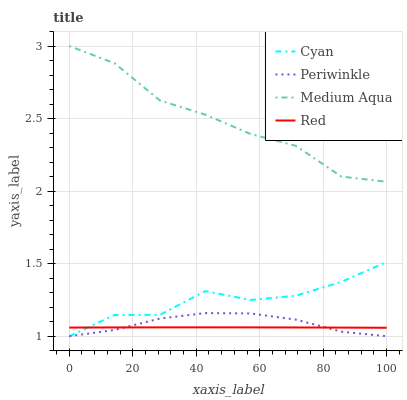Does Red have the minimum area under the curve?
Answer yes or no. Yes. Does Medium Aqua have the maximum area under the curve?
Answer yes or no. Yes. Does Cyan have the minimum area under the curve?
Answer yes or no. No. Does Cyan have the maximum area under the curve?
Answer yes or no. No. Is Red the smoothest?
Answer yes or no. Yes. Is Cyan the roughest?
Answer yes or no. Yes. Is Periwinkle the smoothest?
Answer yes or no. No. Is Periwinkle the roughest?
Answer yes or no. No. Does Cyan have the lowest value?
Answer yes or no. Yes. Does Red have the lowest value?
Answer yes or no. No. Does Medium Aqua have the highest value?
Answer yes or no. Yes. Does Cyan have the highest value?
Answer yes or no. No. Is Red less than Medium Aqua?
Answer yes or no. Yes. Is Medium Aqua greater than Red?
Answer yes or no. Yes. Does Periwinkle intersect Red?
Answer yes or no. Yes. Is Periwinkle less than Red?
Answer yes or no. No. Is Periwinkle greater than Red?
Answer yes or no. No. Does Red intersect Medium Aqua?
Answer yes or no. No. 